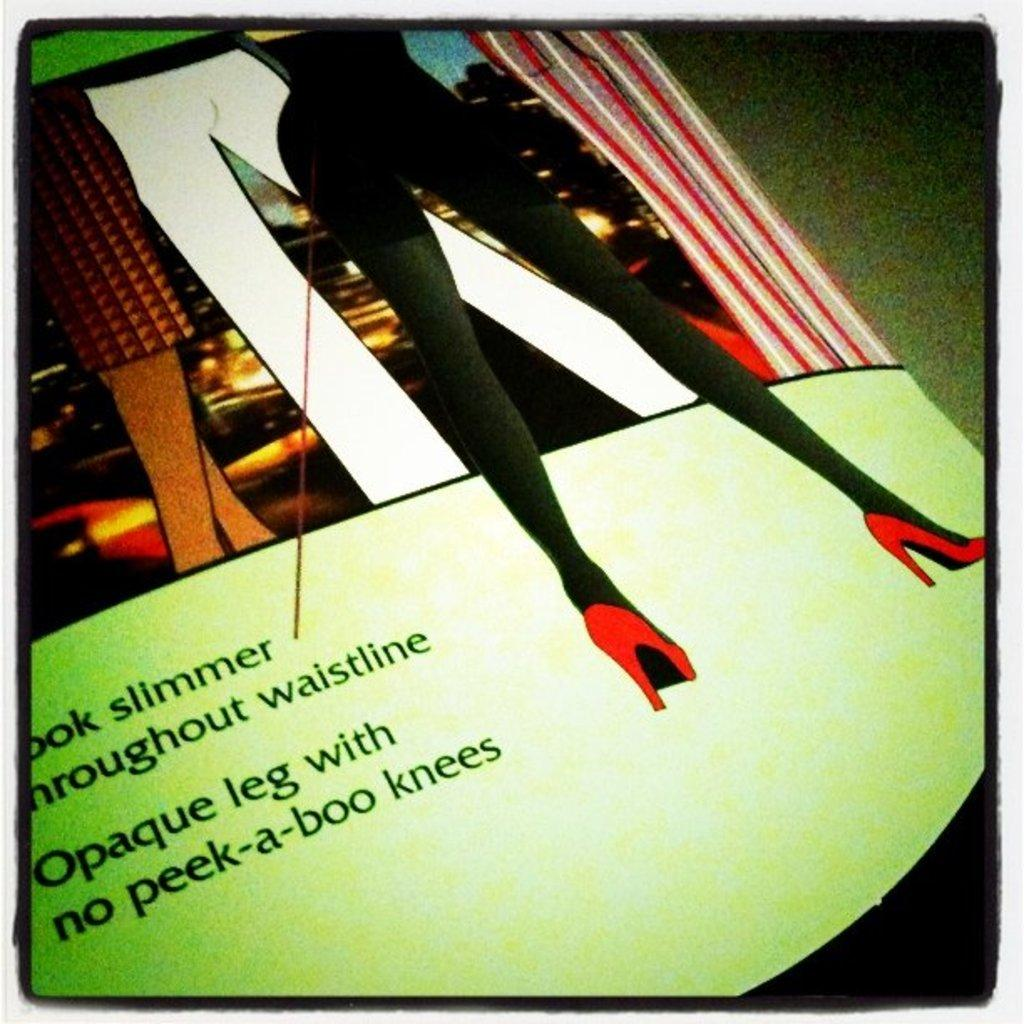What is the main subject of the image? The main subject of the image is a poster. What is depicted on the poster? The poster depicts the legs of persons. Is there any text present in the image? Yes, there is some text in the bottom left corner of the image. What type of plastic material is used to make the legs on the poster? The poster is a two-dimensional representation, and there is no plastic material used to make the legs depicted on it. 